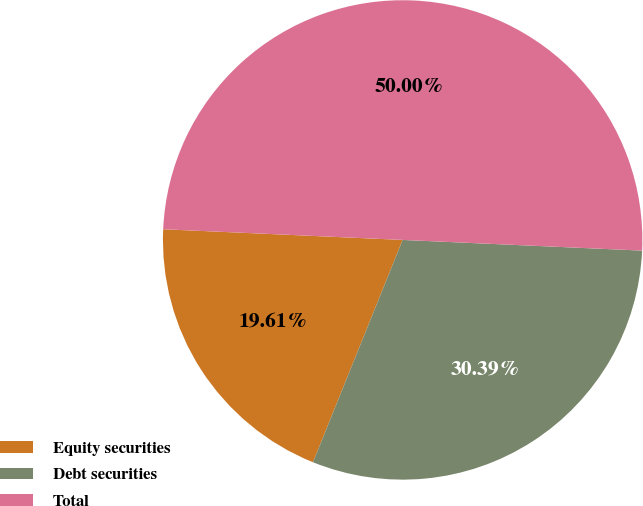Convert chart. <chart><loc_0><loc_0><loc_500><loc_500><pie_chart><fcel>Equity securities<fcel>Debt securities<fcel>Total<nl><fcel>19.61%<fcel>30.39%<fcel>50.0%<nl></chart> 